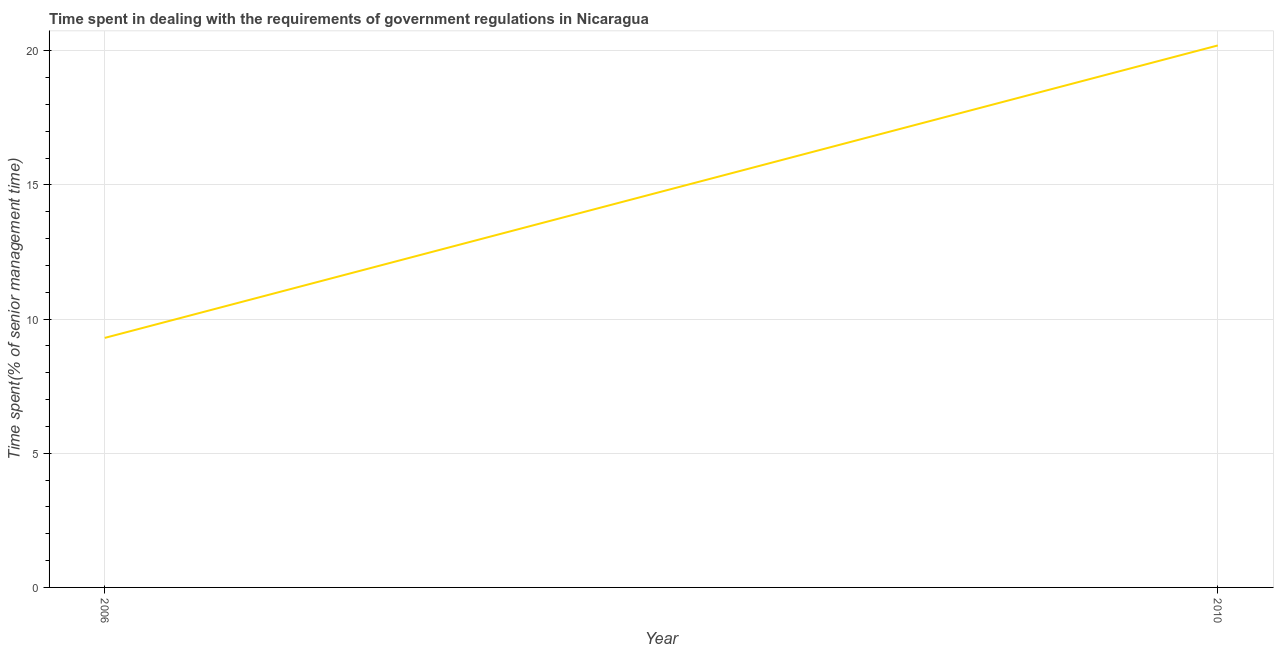What is the time spent in dealing with government regulations in 2010?
Offer a terse response. 20.2. Across all years, what is the maximum time spent in dealing with government regulations?
Offer a terse response. 20.2. What is the sum of the time spent in dealing with government regulations?
Your response must be concise. 29.5. What is the difference between the time spent in dealing with government regulations in 2006 and 2010?
Give a very brief answer. -10.9. What is the average time spent in dealing with government regulations per year?
Offer a terse response. 14.75. What is the median time spent in dealing with government regulations?
Give a very brief answer. 14.75. Do a majority of the years between 2010 and 2006 (inclusive) have time spent in dealing with government regulations greater than 11 %?
Make the answer very short. No. What is the ratio of the time spent in dealing with government regulations in 2006 to that in 2010?
Ensure brevity in your answer.  0.46. Does the time spent in dealing with government regulations monotonically increase over the years?
Ensure brevity in your answer.  Yes. How many years are there in the graph?
Your answer should be compact. 2. Does the graph contain any zero values?
Offer a terse response. No. What is the title of the graph?
Your response must be concise. Time spent in dealing with the requirements of government regulations in Nicaragua. What is the label or title of the X-axis?
Offer a very short reply. Year. What is the label or title of the Y-axis?
Offer a very short reply. Time spent(% of senior management time). What is the Time spent(% of senior management time) in 2010?
Offer a very short reply. 20.2. What is the difference between the Time spent(% of senior management time) in 2006 and 2010?
Offer a very short reply. -10.9. What is the ratio of the Time spent(% of senior management time) in 2006 to that in 2010?
Your response must be concise. 0.46. 